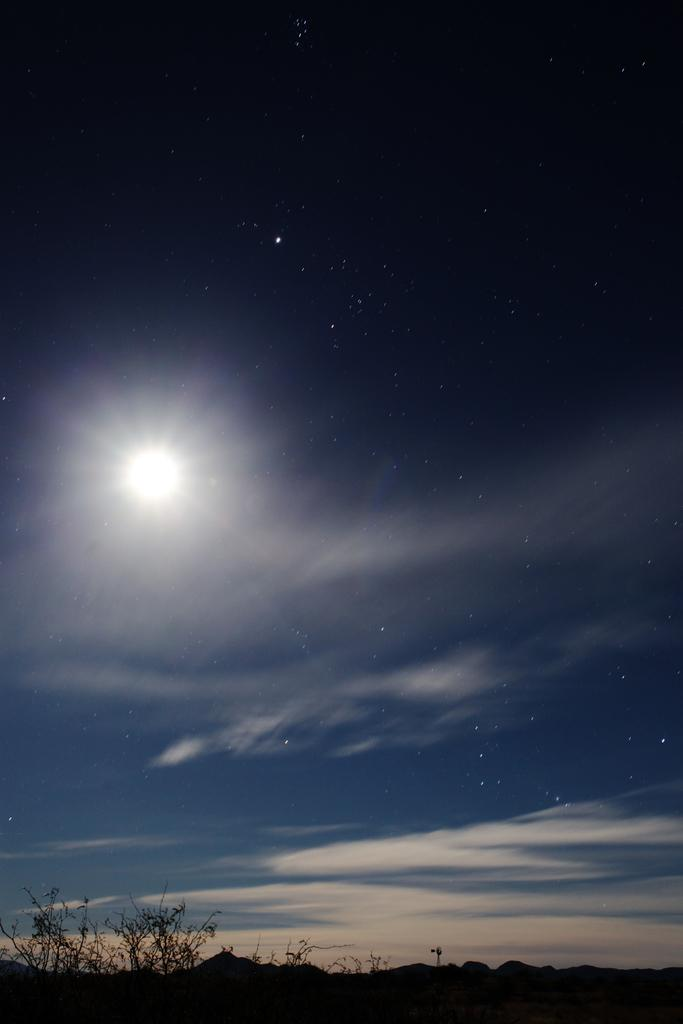What type of ground cover is present in the image? There is grass on the ground in the image. What other vegetation can be seen on the ground in the image? There are plants on the ground in the image. What can be seen in the sky in the image? Clouds, stars, and the moon are visible in the sky in the image. What type of pencil can be seen in the image? There is no pencil present in the image. Can you describe the toad's habitat in the image? There is no toad present in the image. 